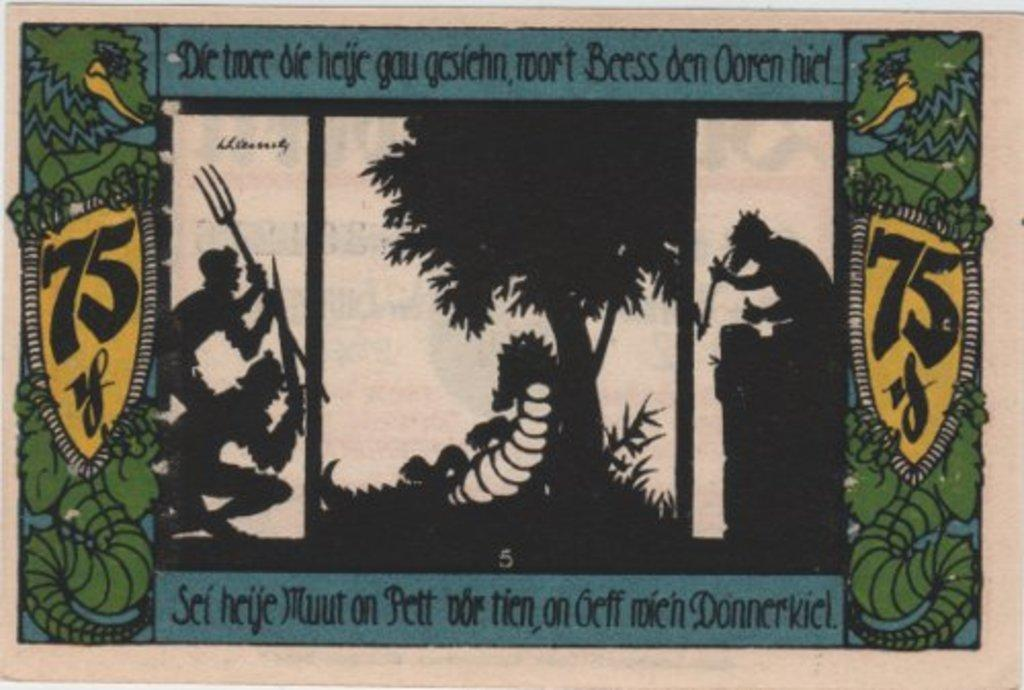What type of visual is the image? The image is a poster. How many people are depicted in the poster? There are three persons in the poster. What are the persons holding in the poster? The persons are holding weapons. What type of natural element is present in the poster? There is a tree in the poster. What else can be found on the poster besides the people and the tree? Text is written on the poster. What type of church can be seen in the poster? There is no church present in the poster; it features three persons holding weapons, a tree, and text. What type of quilt is being used as a weapon by one of the persons in the poster? There is no quilt present in the poster, nor is any weapon depicted as a quilt. 